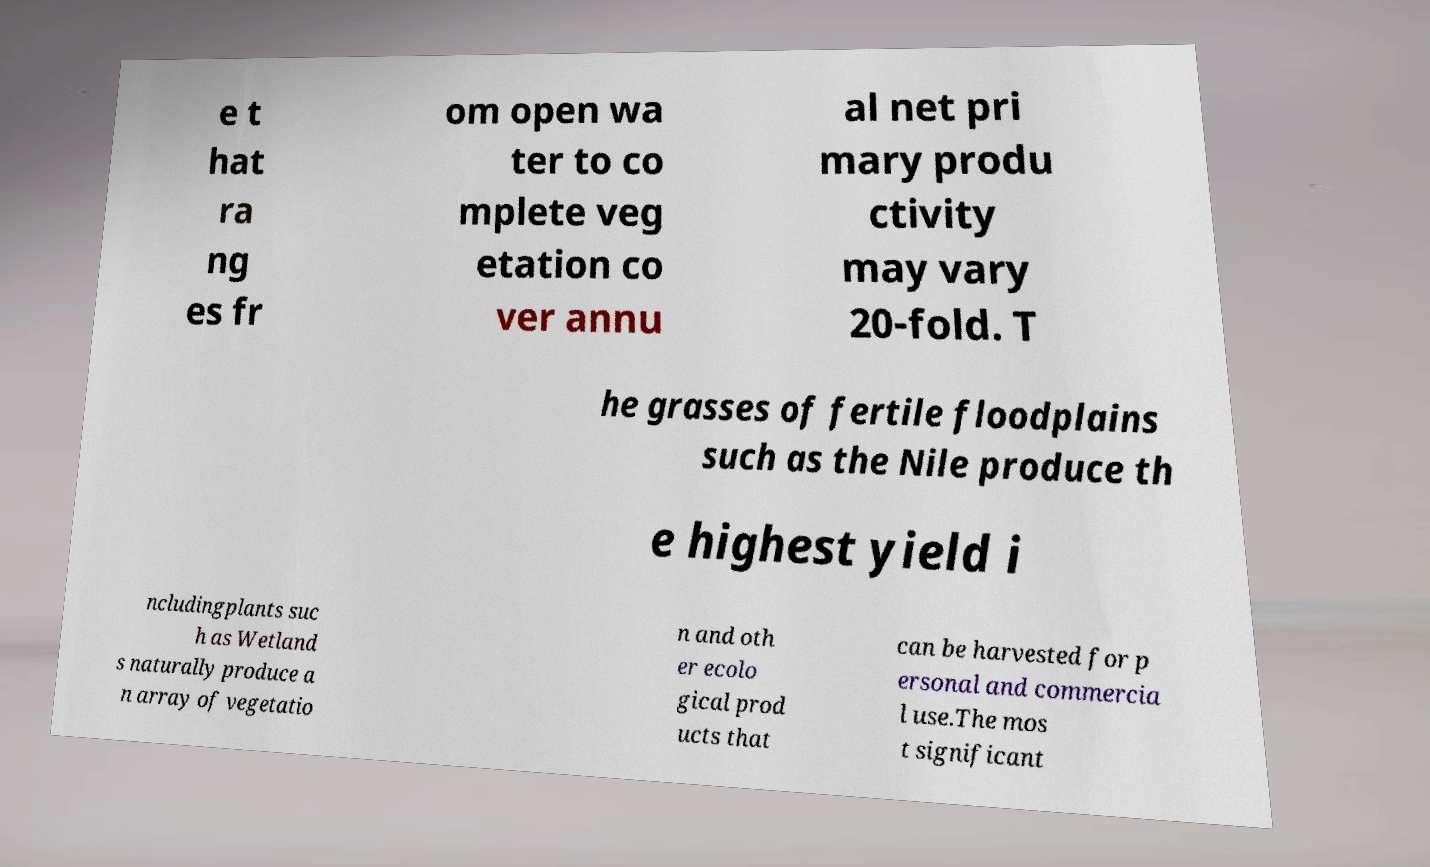Could you extract and type out the text from this image? e t hat ra ng es fr om open wa ter to co mplete veg etation co ver annu al net pri mary produ ctivity may vary 20-fold. T he grasses of fertile floodplains such as the Nile produce th e highest yield i ncludingplants suc h as Wetland s naturally produce a n array of vegetatio n and oth er ecolo gical prod ucts that can be harvested for p ersonal and commercia l use.The mos t significant 